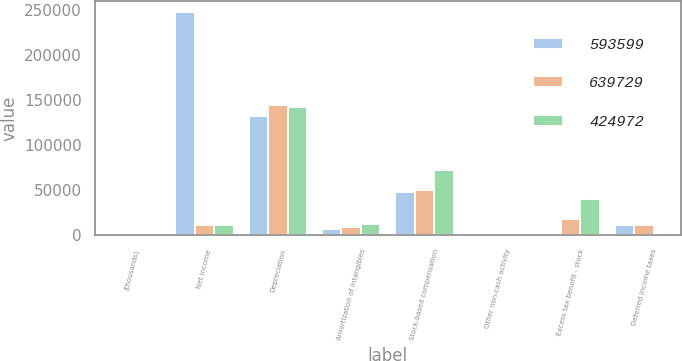<chart> <loc_0><loc_0><loc_500><loc_500><stacked_bar_chart><ecel><fcel>(thousands)<fcel>Net income<fcel>Depreciation<fcel>Amortization of intangibles<fcel>Stock-based compensation<fcel>Other non-cash activity<fcel>Excess tax benefit - stock<fcel>Deferred income taxes<nl><fcel>593599<fcel>2009<fcel>247772<fcel>132493<fcel>7377<fcel>48613<fcel>1663<fcel>20<fcel>11595<nl><fcel>639729<fcel>2008<fcel>11482<fcel>144222<fcel>9250<fcel>50247<fcel>310<fcel>18586<fcel>11369<nl><fcel>424972<fcel>2007<fcel>11482<fcel>142173<fcel>12610<fcel>72652<fcel>853<fcel>40871<fcel>2850<nl></chart> 